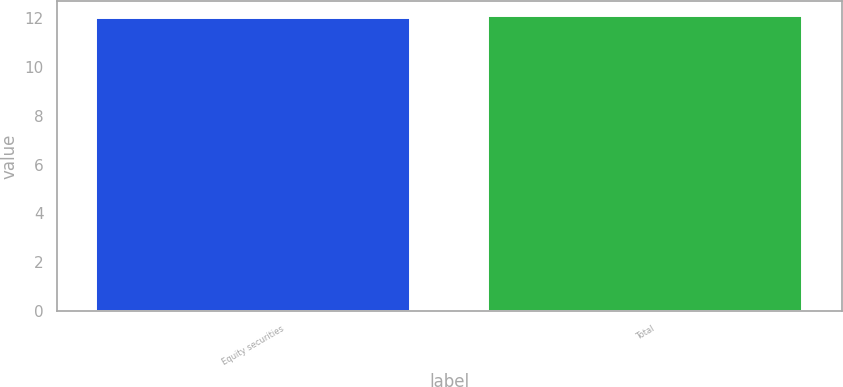<chart> <loc_0><loc_0><loc_500><loc_500><bar_chart><fcel>Equity securities<fcel>Total<nl><fcel>12<fcel>12.1<nl></chart> 